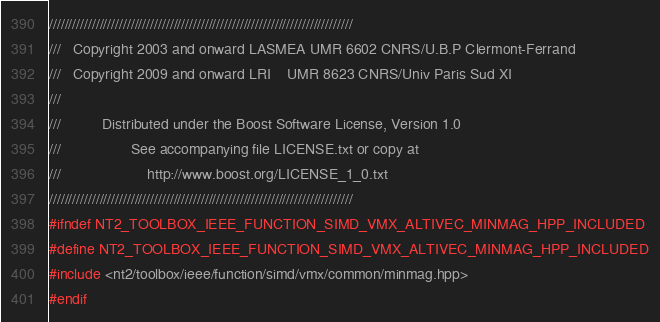<code> <loc_0><loc_0><loc_500><loc_500><_C++_>//////////////////////////////////////////////////////////////////////////////
///   Copyright 2003 and onward LASMEA UMR 6602 CNRS/U.B.P Clermont-Ferrand
///   Copyright 2009 and onward LRI    UMR 8623 CNRS/Univ Paris Sud XI
///
///          Distributed under the Boost Software License, Version 1.0
///                 See accompanying file LICENSE.txt or copy at
///                     http://www.boost.org/LICENSE_1_0.txt
//////////////////////////////////////////////////////////////////////////////
#ifndef NT2_TOOLBOX_IEEE_FUNCTION_SIMD_VMX_ALTIVEC_MINMAG_HPP_INCLUDED
#define NT2_TOOLBOX_IEEE_FUNCTION_SIMD_VMX_ALTIVEC_MINMAG_HPP_INCLUDED
#include <nt2/toolbox/ieee/function/simd/vmx/common/minmag.hpp>
#endif
</code> 